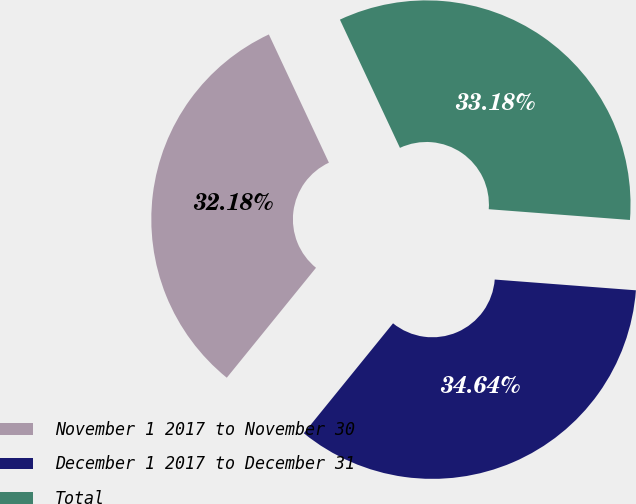Convert chart to OTSL. <chart><loc_0><loc_0><loc_500><loc_500><pie_chart><fcel>November 1 2017 to November 30<fcel>December 1 2017 to December 31<fcel>Total<nl><fcel>32.18%<fcel>34.64%<fcel>33.18%<nl></chart> 